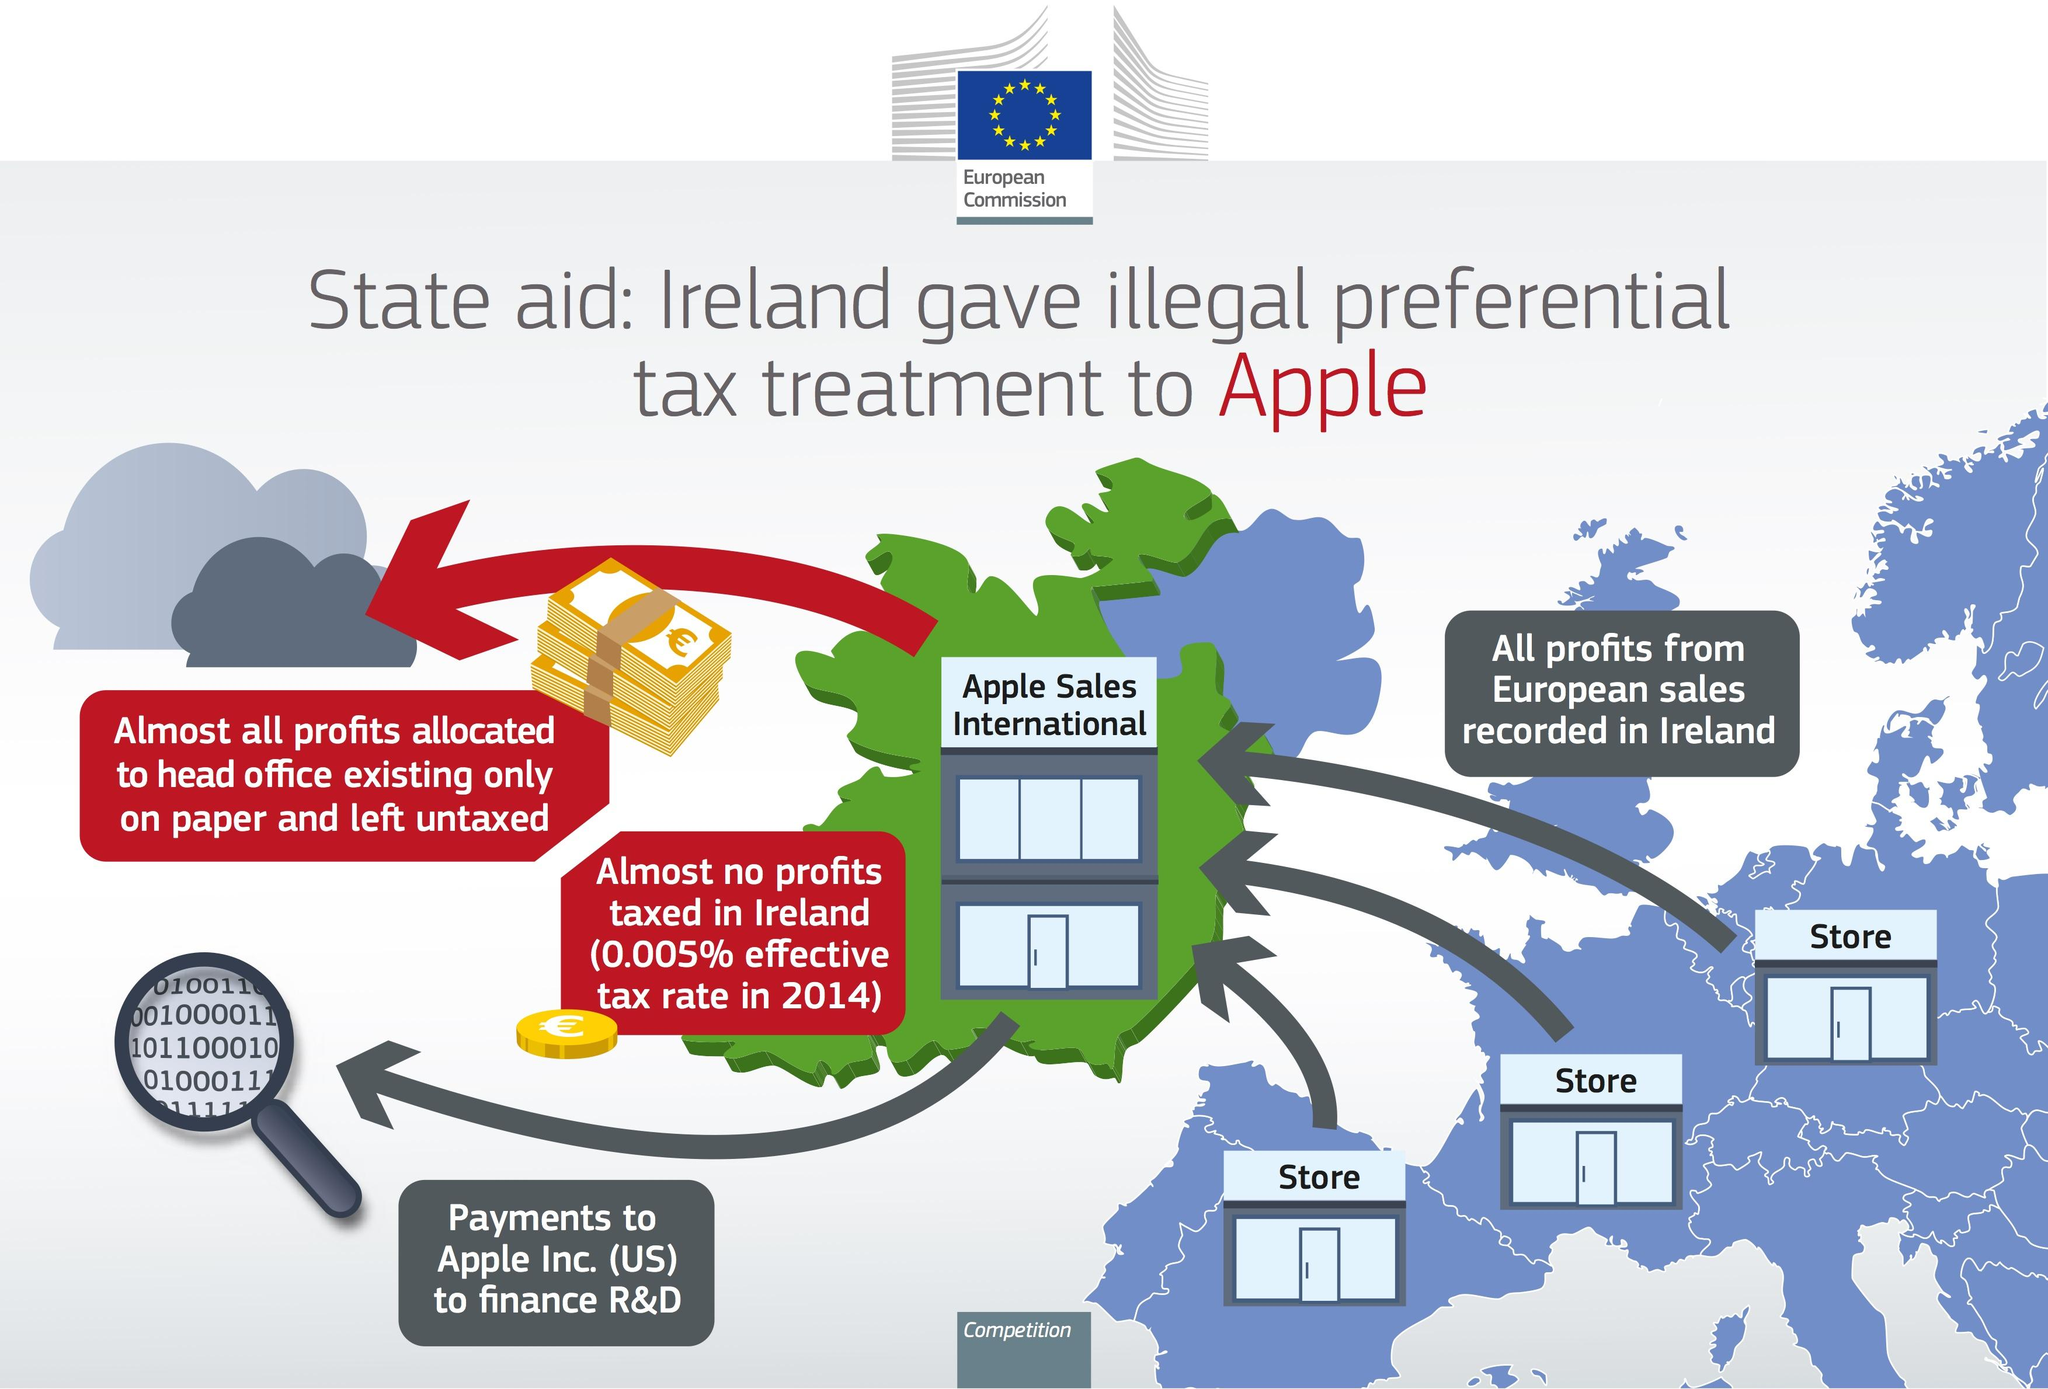Highlight a few significant elements in this photo. Apple has offices and stores in several countries, including the United States and Ireland. 